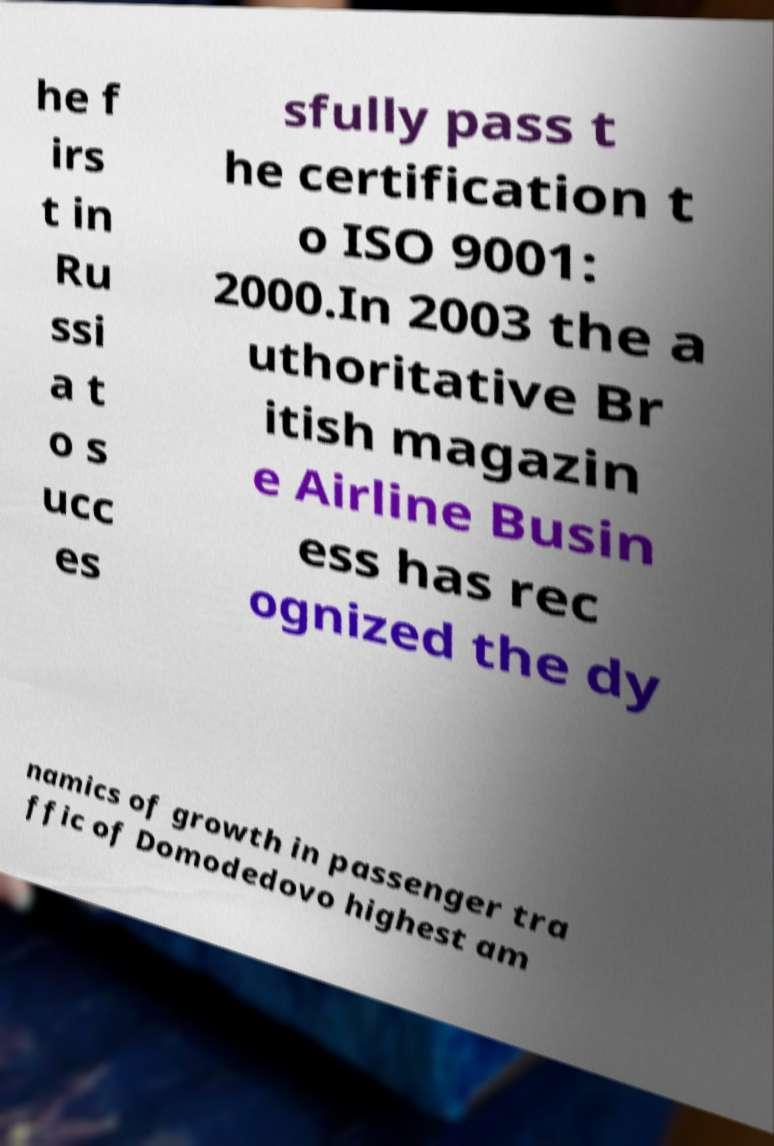Please identify and transcribe the text found in this image. he f irs t in Ru ssi a t o s ucc es sfully pass t he certification t o ISO 9001: 2000.In 2003 the a uthoritative Br itish magazin e Airline Busin ess has rec ognized the dy namics of growth in passenger tra ffic of Domodedovo highest am 